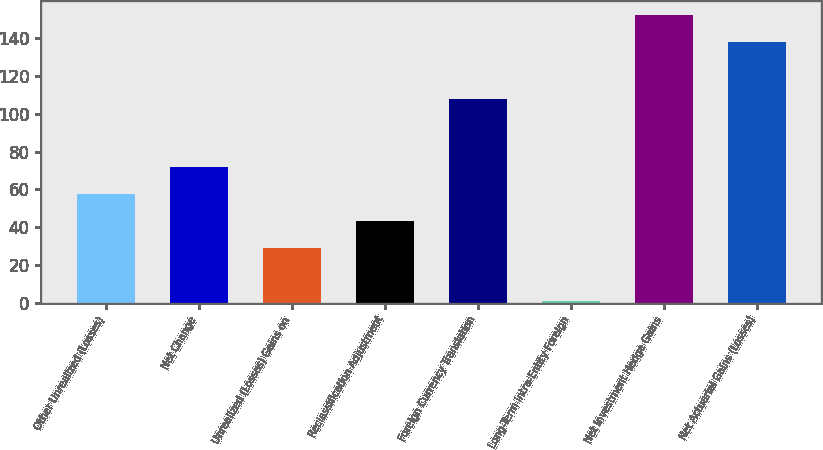Convert chart. <chart><loc_0><loc_0><loc_500><loc_500><bar_chart><fcel>Other Unrealized (Losses)<fcel>Net Change<fcel>Unrealized (Losses) Gains on<fcel>Reclassification Adjustment<fcel>Foreign Currency Translation<fcel>Long-Term Intra-Entity Foreign<fcel>Net Investment Hedge Gains<fcel>Net Actuarial Gains (Losses)<nl><fcel>57.64<fcel>71.8<fcel>29.32<fcel>43.48<fcel>107.8<fcel>1<fcel>151.96<fcel>137.8<nl></chart> 